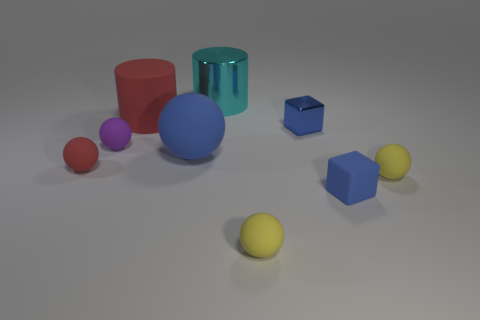Subtract all red matte balls. How many balls are left? 4 Subtract all cyan blocks. How many yellow balls are left? 2 Subtract 1 balls. How many balls are left? 4 Subtract all yellow balls. How many balls are left? 3 Subtract all purple cylinders. Subtract all brown spheres. How many cylinders are left? 2 Subtract all tiny red things. Subtract all tiny blue matte objects. How many objects are left? 7 Add 1 blue things. How many blue things are left? 4 Add 3 gray rubber objects. How many gray rubber objects exist? 3 Subtract 0 brown cylinders. How many objects are left? 9 Subtract all balls. How many objects are left? 4 